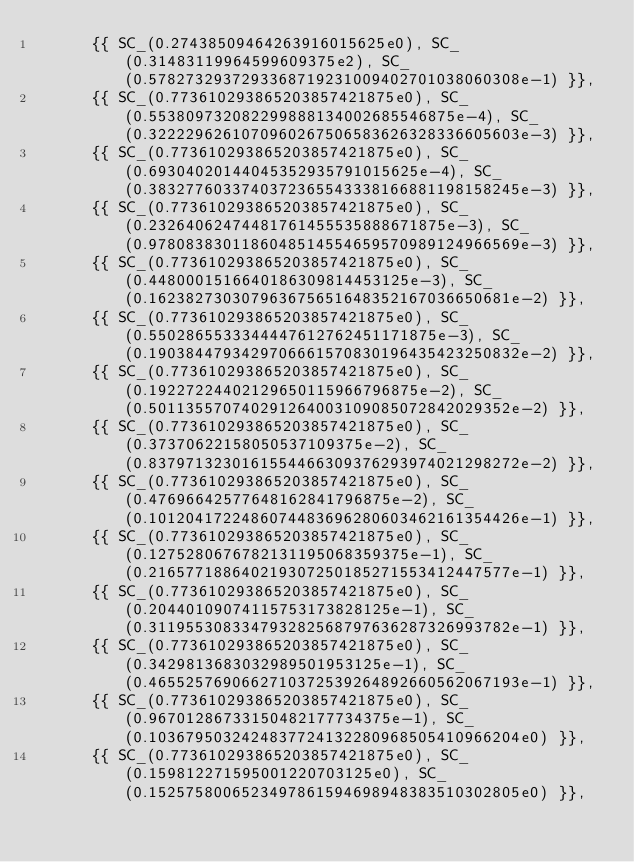Convert code to text. <code><loc_0><loc_0><loc_500><loc_500><_C++_>      {{ SC_(0.27438509464263916015625e0), SC_(0.31483119964599609375e2), SC_(0.5782732937293368719231009402701038060308e-1) }}, 
      {{ SC_(0.773610293865203857421875e0), SC_(0.553809732082299888134002685546875e-4), SC_(0.3222296261070960267506583626328336605603e-3) }}, 
      {{ SC_(0.773610293865203857421875e0), SC_(0.69304020144045352935791015625e-4), SC_(0.3832776033740372365543338166881198158245e-3) }}, 
      {{ SC_(0.773610293865203857421875e0), SC_(0.23264062474481761455535888671875e-3), SC_(0.9780838301186048514554659570989124966569e-3) }}, 
      {{ SC_(0.773610293865203857421875e0), SC_(0.4480001516640186309814453125e-3), SC_(0.162382730307963675651648352167036650681e-2) }}, 
      {{ SC_(0.773610293865203857421875e0), SC_(0.5502865533344447612762451171875e-3), SC_(0.1903844793429706661570830196435423250832e-2) }}, 
      {{ SC_(0.773610293865203857421875e0), SC_(0.19227224402129650115966796875e-2), SC_(0.501135570740291264003109085072842029352e-2) }}, 
      {{ SC_(0.773610293865203857421875e0), SC_(0.37370622158050537109375e-2), SC_(0.8379713230161554466309376293974021298272e-2) }}, 
      {{ SC_(0.773610293865203857421875e0), SC_(0.47696642577648162841796875e-2), SC_(0.1012041722486074483696280603462161354426e-1) }}, 
      {{ SC_(0.773610293865203857421875e0), SC_(0.1275280676782131195068359375e-1), SC_(0.216577188640219307250185271553412447577e-1) }}, 
      {{ SC_(0.773610293865203857421875e0), SC_(0.20440109074115753173828125e-1), SC_(0.311955308334793282568797636287326993782e-1) }}, 
      {{ SC_(0.773610293865203857421875e0), SC_(0.3429813683032989501953125e-1), SC_(0.4655257690662710372539264892660562067193e-1) }}, 
      {{ SC_(0.773610293865203857421875e0), SC_(0.96701286733150482177734375e-1), SC_(0.1036795032424837724132280968505410966204e0) }}, 
      {{ SC_(0.773610293865203857421875e0), SC_(0.159812271595001220703125e0), SC_(0.1525758006523497861594698948383510302805e0) }}, </code> 